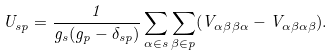<formula> <loc_0><loc_0><loc_500><loc_500>U _ { s p } = \frac { 1 } { g _ { s } ( g _ { p } - \delta _ { s p } ) } \sum _ { \alpha \in s } \sum _ { \beta \in p } ( V _ { \alpha \beta \beta \alpha } - V _ { \alpha \beta \alpha \beta } ) .</formula> 